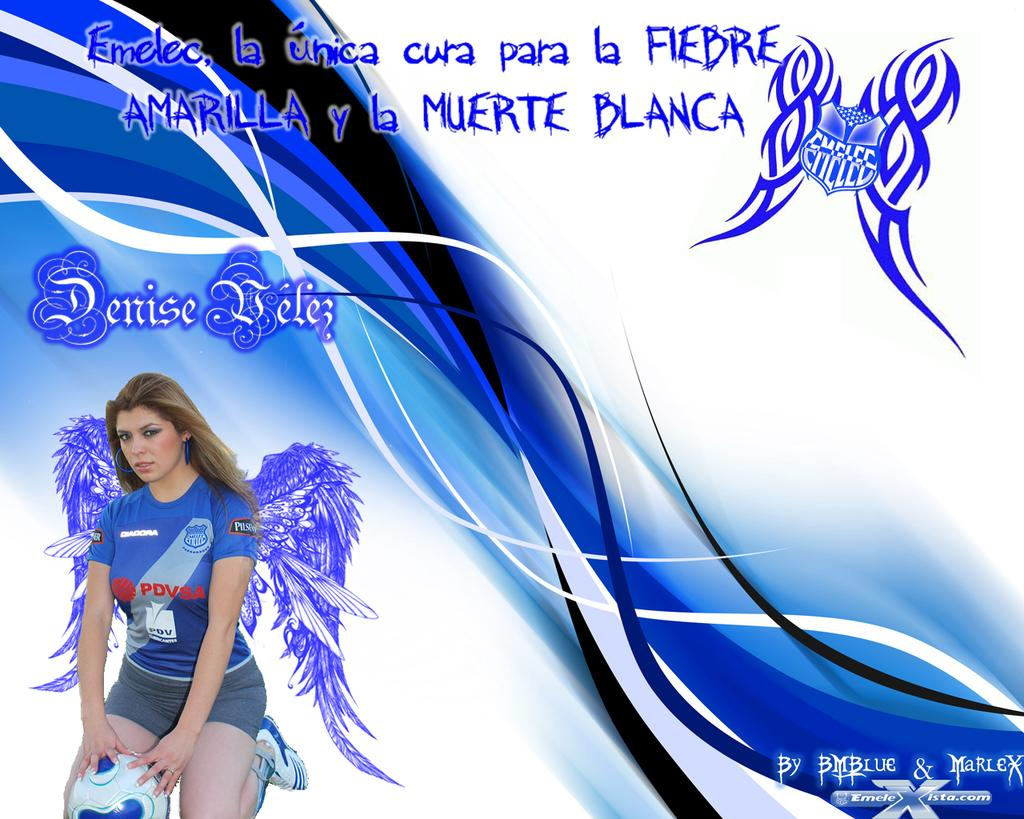<image>
Provide a brief description of the given image. A picture of Denise Velez in a blue PDVSA shirt is on an ad for Amarilla y la Muerte Blanca 